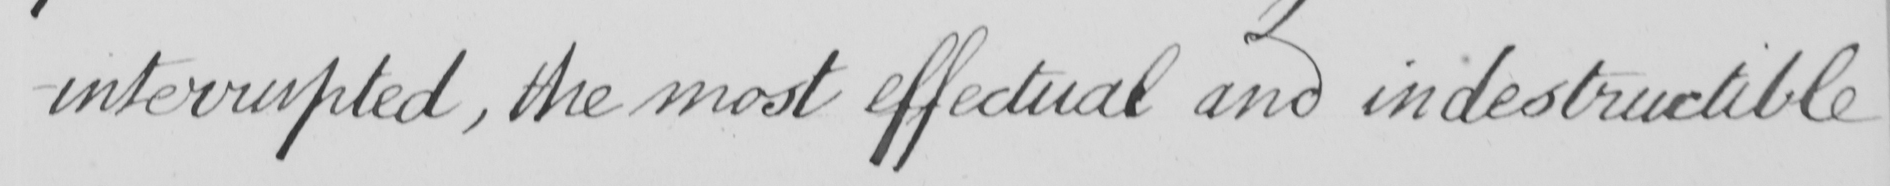Please transcribe the handwritten text in this image. -interrupted , the most effectual and indestructible 